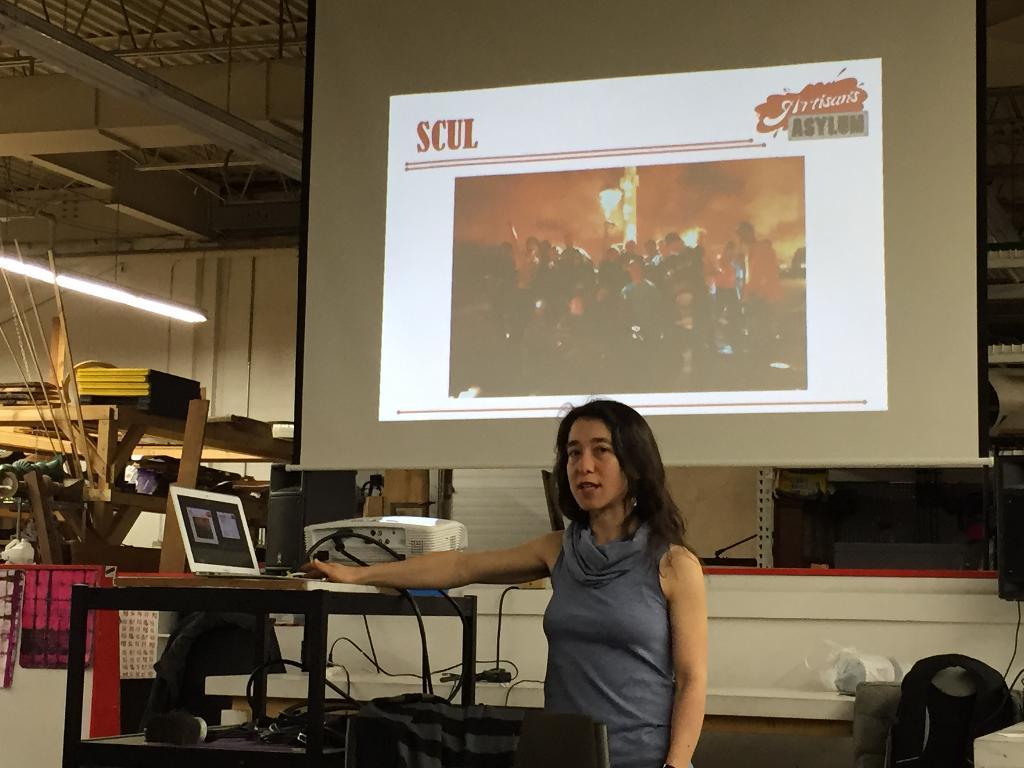What is written in the top left of this slide?
Provide a succinct answer. Scul. Is an asylum mentioned?
Provide a succinct answer. Yes. 